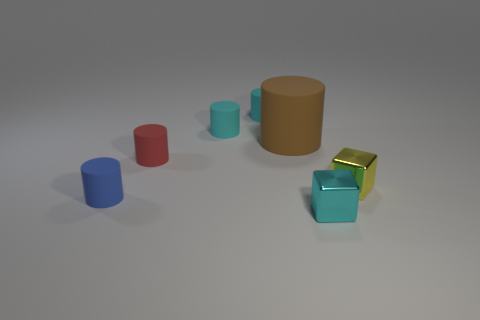Does the cube that is behind the tiny blue object have the same material as the object to the left of the red thing?
Your answer should be compact. No. What size is the brown cylinder that is behind the shiny block that is behind the tiny cyan shiny cube?
Offer a very short reply. Large. What shape is the large brown rubber thing?
Your response must be concise. Cylinder. What number of tiny cyan matte cylinders are left of the small blue rubber thing?
Your answer should be very brief. 0. What number of things are the same material as the yellow cube?
Your answer should be compact. 1. Is the block in front of the small blue matte object made of the same material as the small yellow thing?
Offer a terse response. Yes. Are any red shiny cubes visible?
Your response must be concise. No. How big is the thing that is both to the right of the large object and to the left of the yellow shiny block?
Offer a terse response. Small. Is the number of large brown things in front of the small blue rubber object greater than the number of small red things to the left of the small red matte cylinder?
Offer a very short reply. No. What color is the large rubber object?
Ensure brevity in your answer.  Brown. 